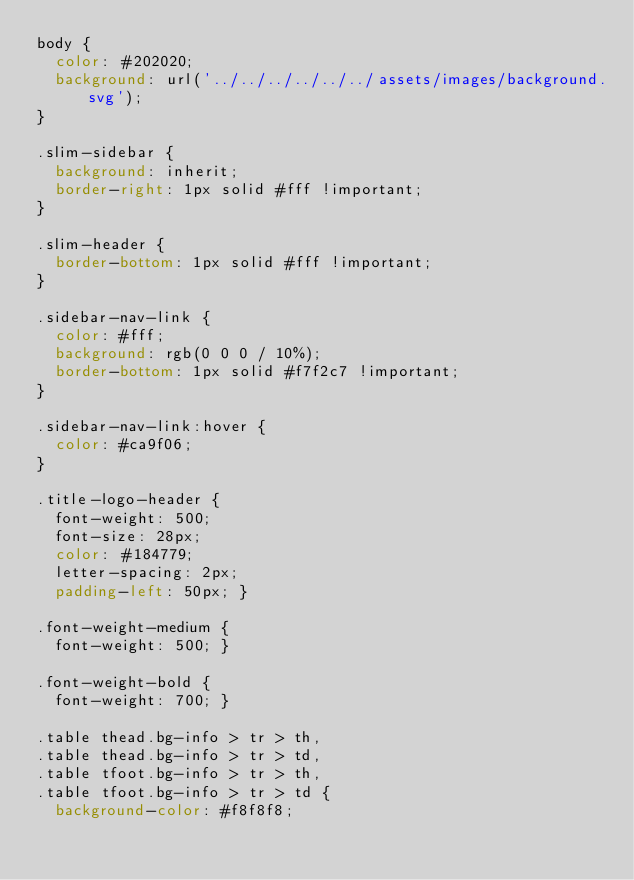<code> <loc_0><loc_0><loc_500><loc_500><_CSS_>body {
  color: #202020;
  background: url('../../../../../../assets/images/background.svg');
}

.slim-sidebar {
  background: inherit;
  border-right: 1px solid #fff !important;
}

.slim-header {
  border-bottom: 1px solid #fff !important;
}

.sidebar-nav-link {
  color: #fff;
  background: rgb(0 0 0 / 10%);
  border-bottom: 1px solid #f7f2c7 !important;
}

.sidebar-nav-link:hover {
  color: #ca9f06;
}

.title-logo-header {
  font-weight: 500;
  font-size: 28px;
  color: #184779;
  letter-spacing: 2px;
  padding-left: 50px; }

.font-weight-medium {
  font-weight: 500; }

.font-weight-bold {
  font-weight: 700; }

.table thead.bg-info > tr > th,
.table thead.bg-info > tr > td,
.table tfoot.bg-info > tr > th,
.table tfoot.bg-info > tr > td {
  background-color: #f8f8f8;</code> 